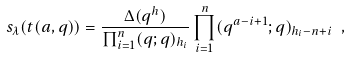<formula> <loc_0><loc_0><loc_500><loc_500>s _ { \lambda } ( { t } ( a , q ) ) = \frac { \Delta ( q ^ { h } ) } { \prod _ { i = 1 } ^ { n } ( q ; q ) _ { h _ { i } } } \prod _ { i = 1 } ^ { n } ( q ^ { a - i + 1 } ; q ) _ { h _ { i } - n + i } \ ,</formula> 